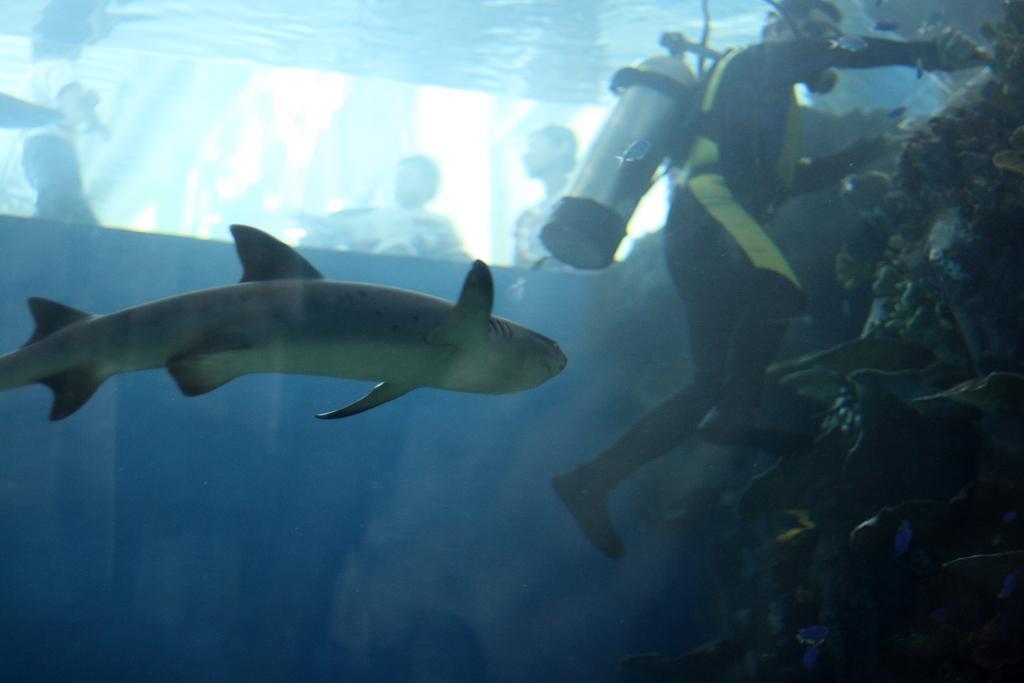Could you give a brief overview of what you see in this image? In the image there is a shark in the water and a person swimming in the back in scuba diving dress and cylinder and over the top there are few persons visible. 